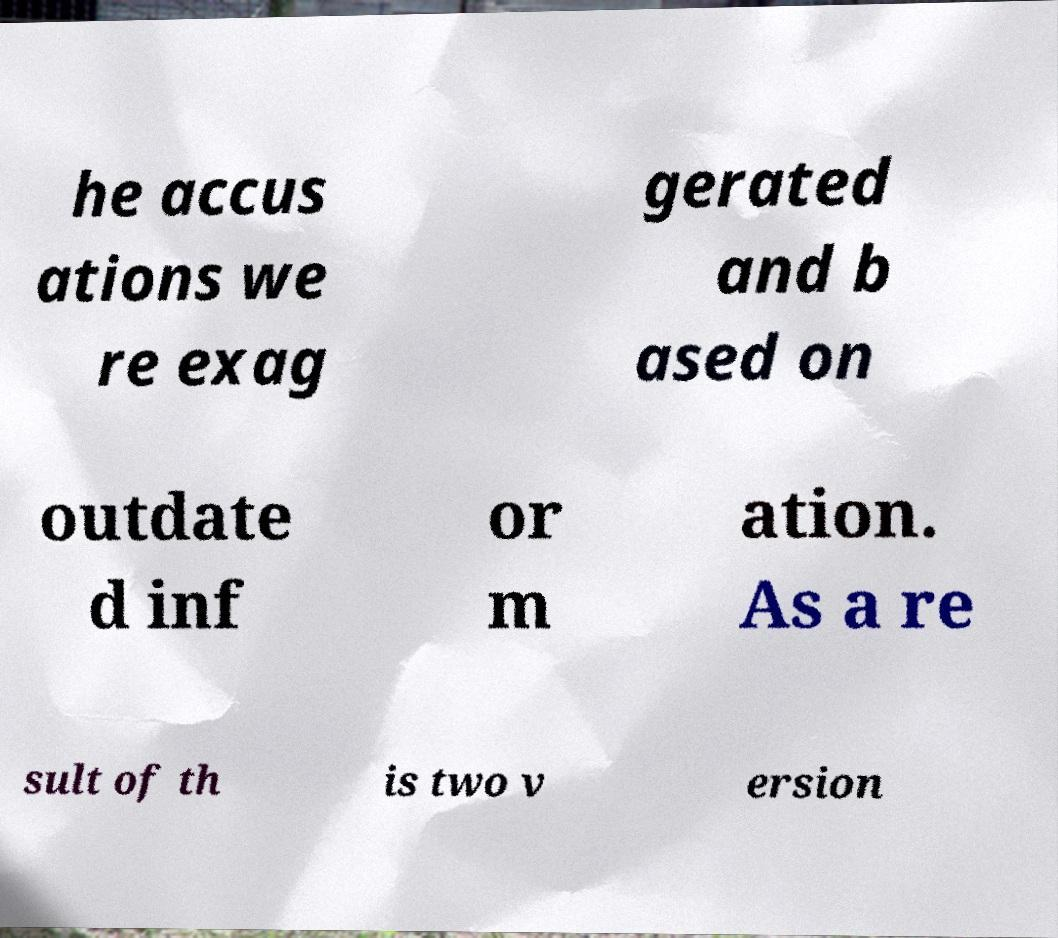There's text embedded in this image that I need extracted. Can you transcribe it verbatim? he accus ations we re exag gerated and b ased on outdate d inf or m ation. As a re sult of th is two v ersion 